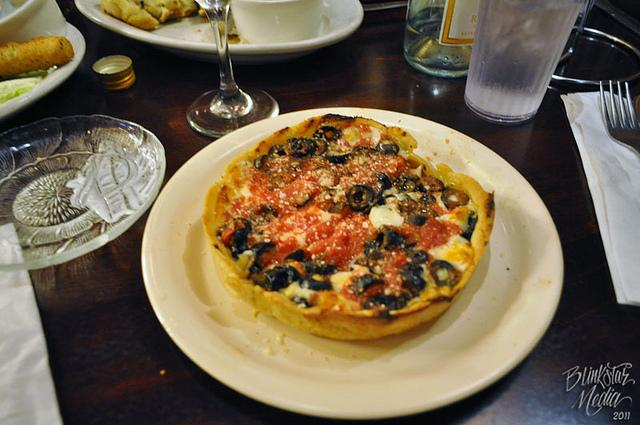What style of pizza is on the plate? deep dish 